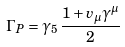Convert formula to latex. <formula><loc_0><loc_0><loc_500><loc_500>\Gamma _ { P } = \gamma _ { 5 } \, \frac { 1 + v _ { \mu } \gamma ^ { \mu } } { 2 }</formula> 